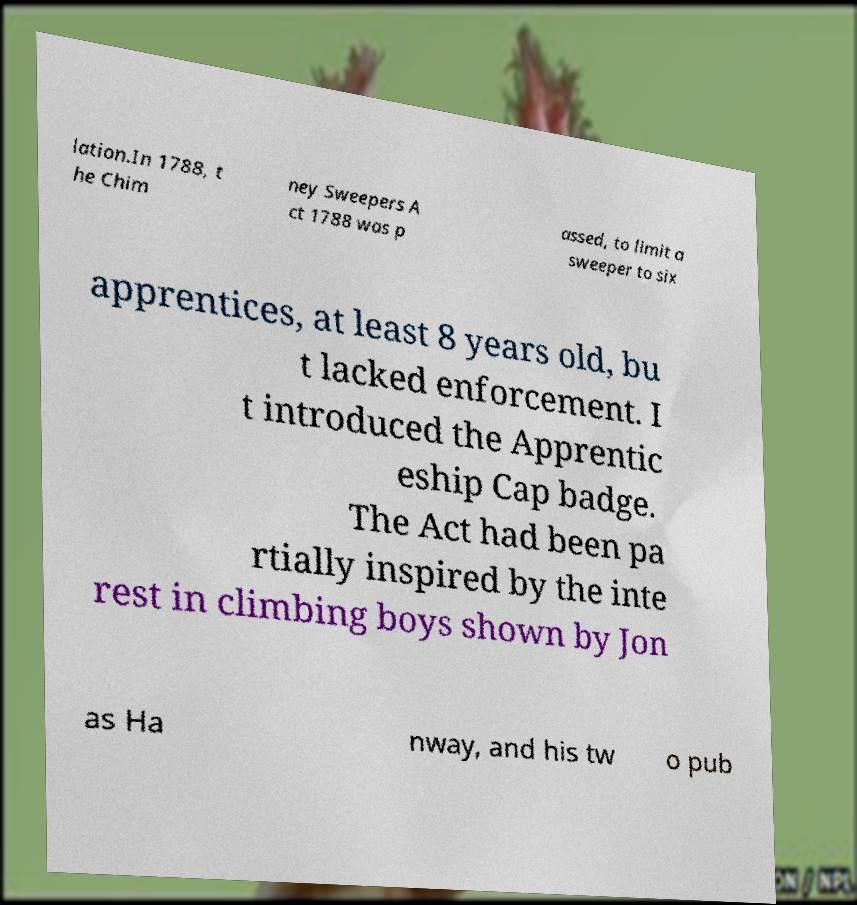Can you read and provide the text displayed in the image?This photo seems to have some interesting text. Can you extract and type it out for me? lation.In 1788, t he Chim ney Sweepers A ct 1788 was p assed, to limit a sweeper to six apprentices, at least 8 years old, bu t lacked enforcement. I t introduced the Apprentic eship Cap badge. The Act had been pa rtially inspired by the inte rest in climbing boys shown by Jon as Ha nway, and his tw o pub 